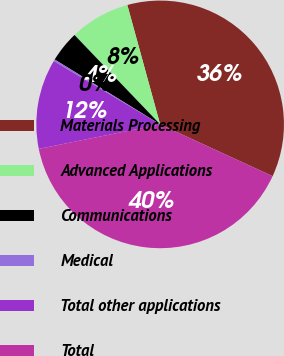<chart> <loc_0><loc_0><loc_500><loc_500><pie_chart><fcel>Materials Processing<fcel>Advanced Applications<fcel>Communications<fcel>Medical<fcel>Total other applications<fcel>Total<nl><fcel>36.14%<fcel>7.89%<fcel>4.06%<fcel>0.24%<fcel>11.71%<fcel>39.96%<nl></chart> 